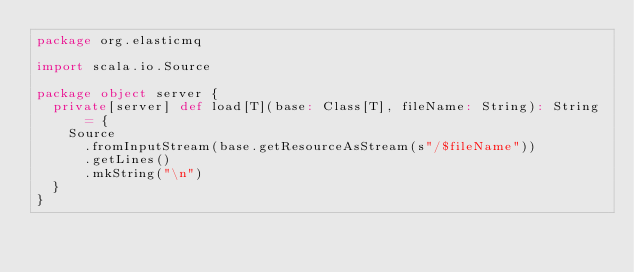<code> <loc_0><loc_0><loc_500><loc_500><_Scala_>package org.elasticmq

import scala.io.Source

package object server {
  private[server] def load[T](base: Class[T], fileName: String): String = {
    Source
      .fromInputStream(base.getResourceAsStream(s"/$fileName"))
      .getLines()
      .mkString("\n")
  }
}
</code> 